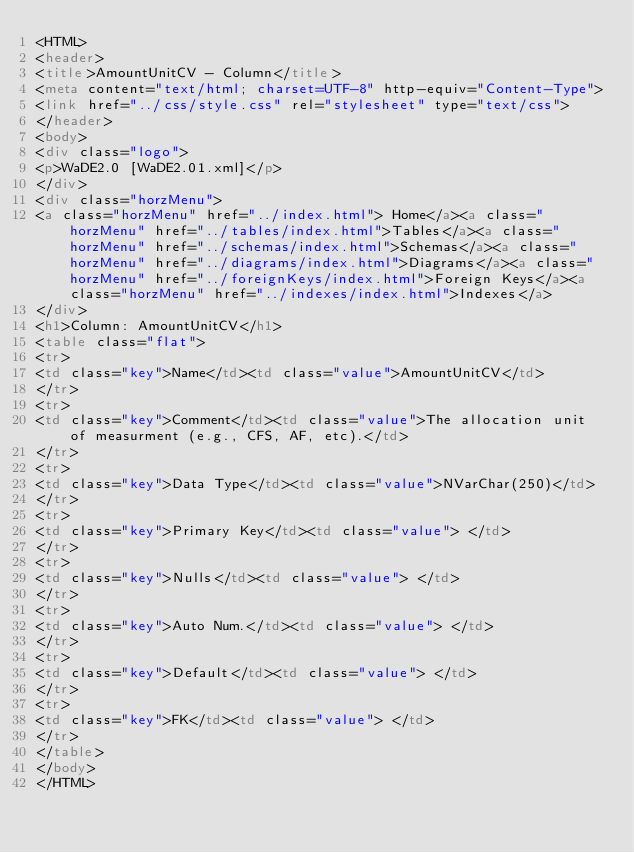<code> <loc_0><loc_0><loc_500><loc_500><_HTML_><HTML>
<header>
<title>AmountUnitCV - Column</title>
<meta content="text/html; charset=UTF-8" http-equiv="Content-Type">
<link href="../css/style.css" rel="stylesheet" type="text/css">
</header>
<body>
<div class="logo">
<p>WaDE2.0 [WaDE2.01.xml]</p>
</div>
<div class="horzMenu">
<a class="horzMenu" href="../index.html"> Home</a><a class="horzMenu" href="../tables/index.html">Tables</a><a class="horzMenu" href="../schemas/index.html">Schemas</a><a class="horzMenu" href="../diagrams/index.html">Diagrams</a><a class="horzMenu" href="../foreignKeys/index.html">Foreign Keys</a><a class="horzMenu" href="../indexes/index.html">Indexes</a>
</div>
<h1>Column: AmountUnitCV</h1>
<table class="flat">
<tr>
<td class="key">Name</td><td class="value">AmountUnitCV</td>
</tr>
<tr>
<td class="key">Comment</td><td class="value">The allocation unit of measurment (e.g., CFS, AF, etc).</td>
</tr>
<tr>
<td class="key">Data Type</td><td class="value">NVarChar(250)</td>
</tr>
<tr>
<td class="key">Primary Key</td><td class="value"> </td>
</tr>
<tr>
<td class="key">Nulls</td><td class="value"> </td>
</tr>
<tr>
<td class="key">Auto Num.</td><td class="value"> </td>
</tr>
<tr>
<td class="key">Default</td><td class="value"> </td>
</tr>
<tr>
<td class="key">FK</td><td class="value"> </td>
</tr>
</table>
</body>
</HTML>
</code> 